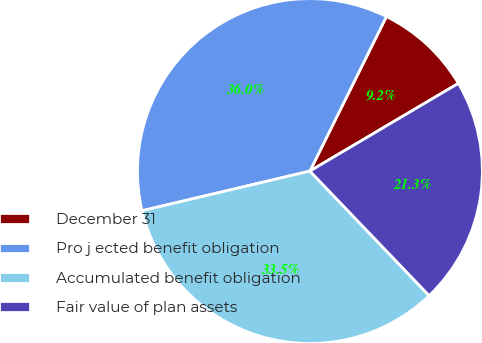Convert chart. <chart><loc_0><loc_0><loc_500><loc_500><pie_chart><fcel>December 31<fcel>Pro j ected benefit obligation<fcel>Accumulated benefit obligation<fcel>Fair value of plan assets<nl><fcel>9.19%<fcel>36.01%<fcel>33.46%<fcel>21.34%<nl></chart> 